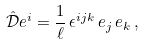Convert formula to latex. <formula><loc_0><loc_0><loc_500><loc_500>\hat { \mathcal { D } } e ^ { i } = \frac { 1 } { \ell } \, \epsilon ^ { i j k } \, e _ { j } \, e _ { k } \, ,</formula> 